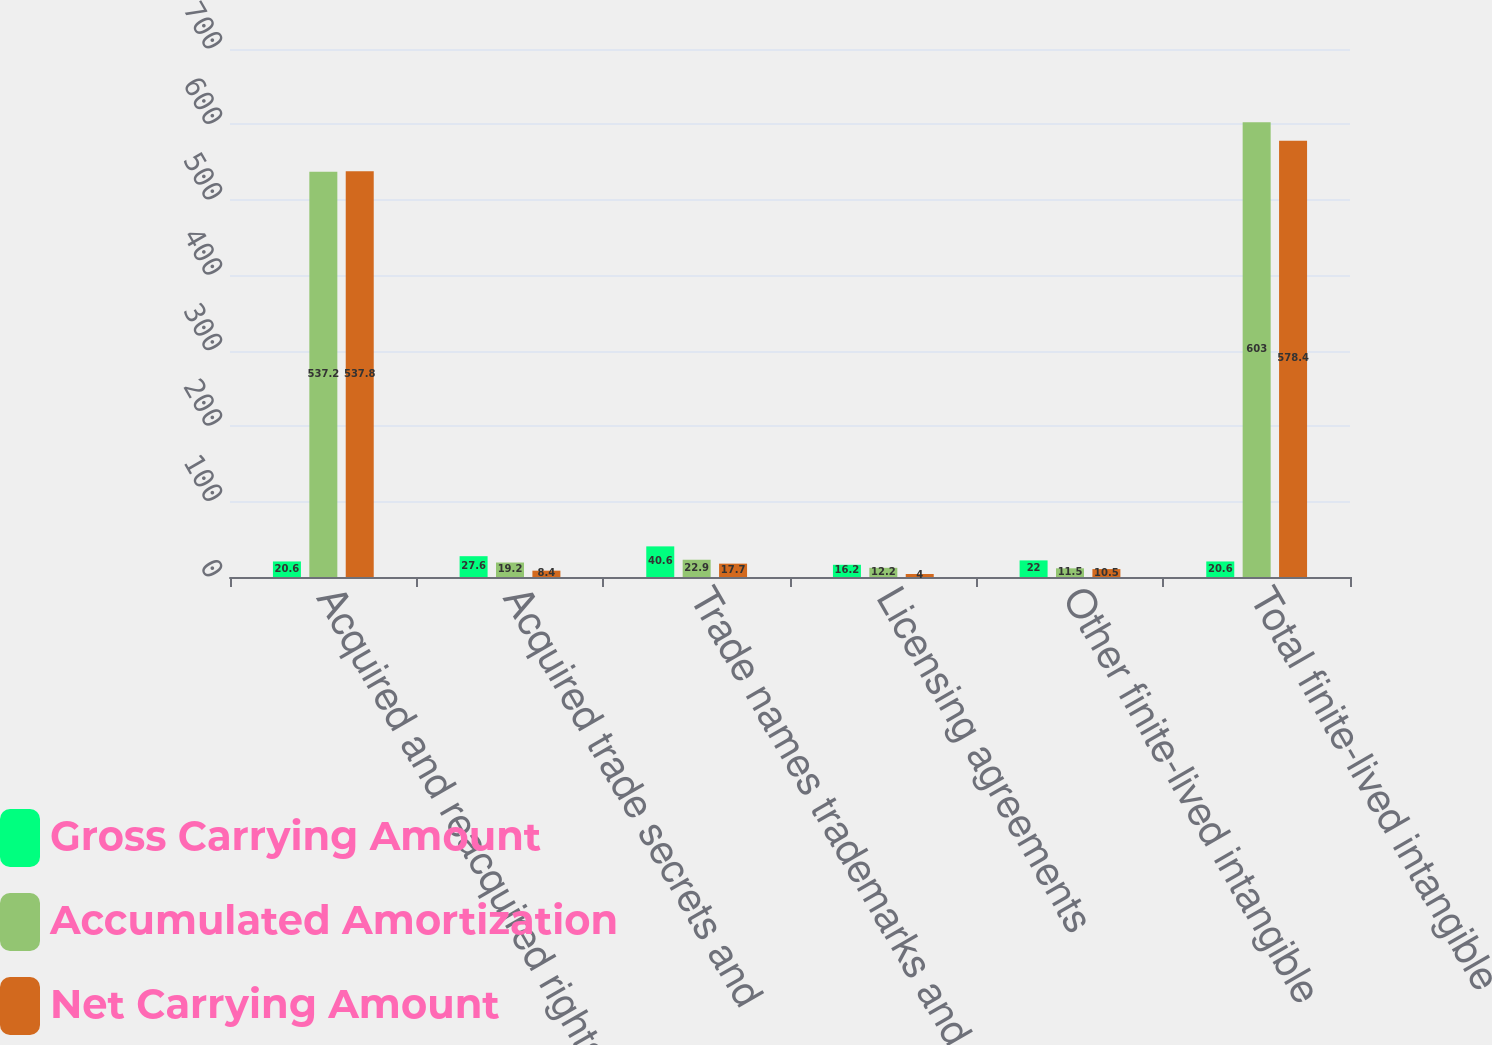Convert chart to OTSL. <chart><loc_0><loc_0><loc_500><loc_500><stacked_bar_chart><ecel><fcel>Acquired and reacquired rights<fcel>Acquired trade secrets and<fcel>Trade names trademarks and<fcel>Licensing agreements<fcel>Other finite-lived intangible<fcel>Total finite-lived intangible<nl><fcel>Gross Carrying Amount<fcel>20.6<fcel>27.6<fcel>40.6<fcel>16.2<fcel>22<fcel>20.6<nl><fcel>Accumulated Amortization<fcel>537.2<fcel>19.2<fcel>22.9<fcel>12.2<fcel>11.5<fcel>603<nl><fcel>Net Carrying Amount<fcel>537.8<fcel>8.4<fcel>17.7<fcel>4<fcel>10.5<fcel>578.4<nl></chart> 